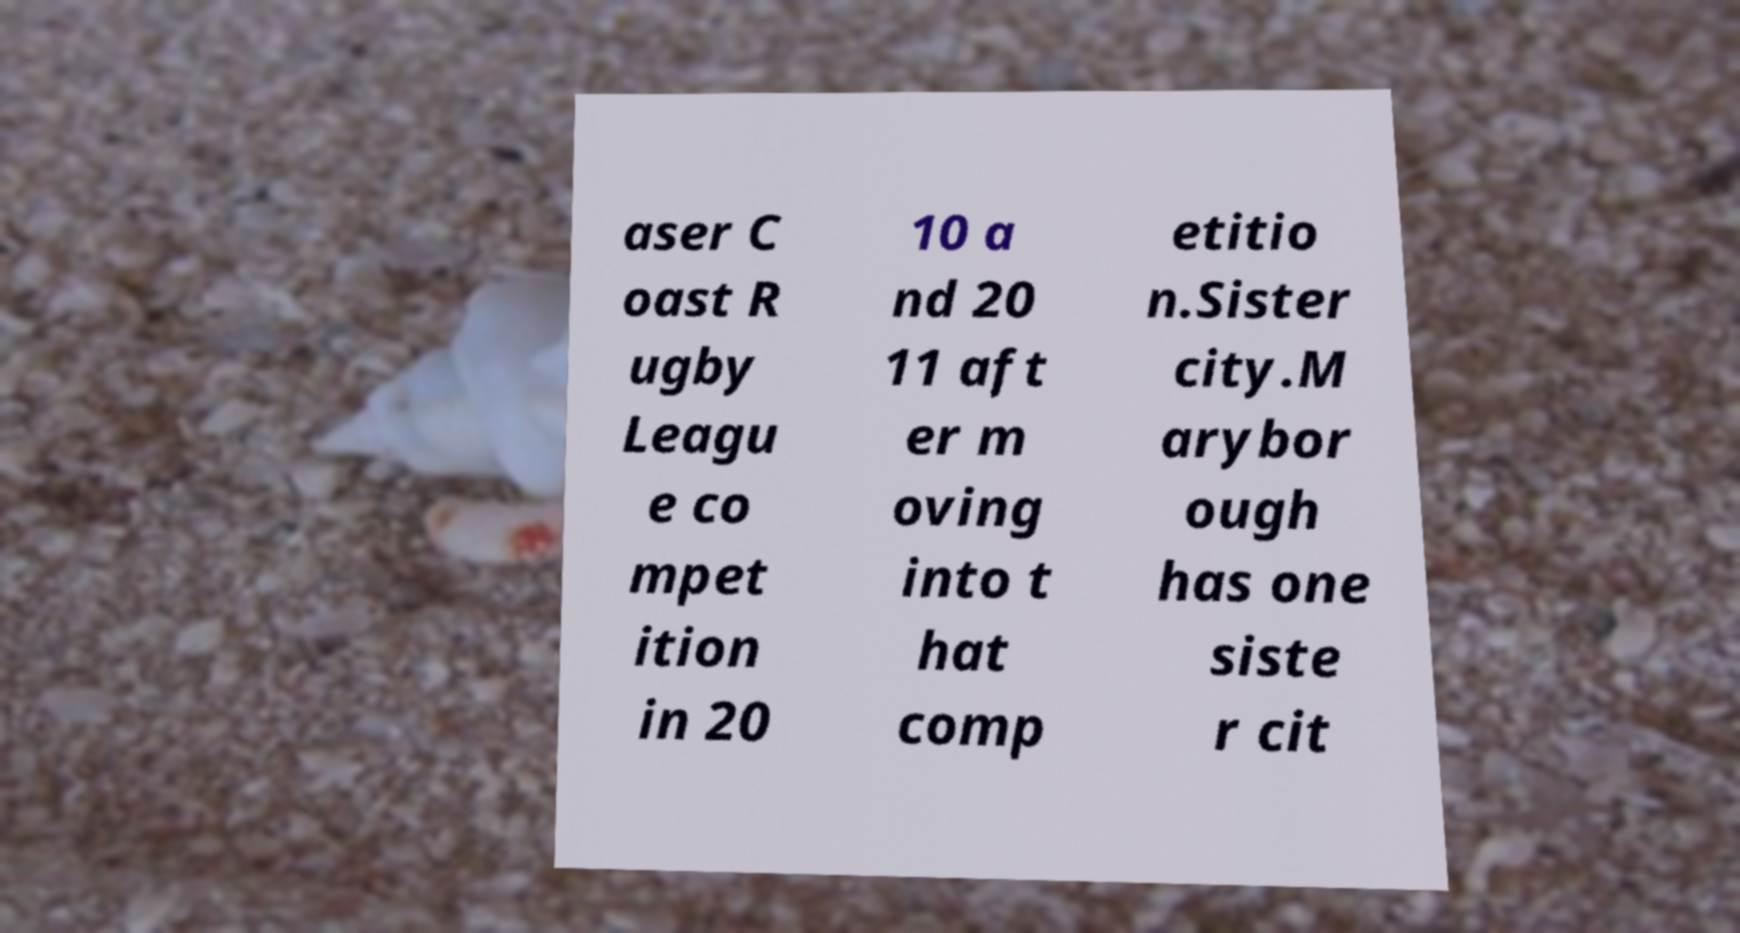Please identify and transcribe the text found in this image. aser C oast R ugby Leagu e co mpet ition in 20 10 a nd 20 11 aft er m oving into t hat comp etitio n.Sister city.M arybor ough has one siste r cit 